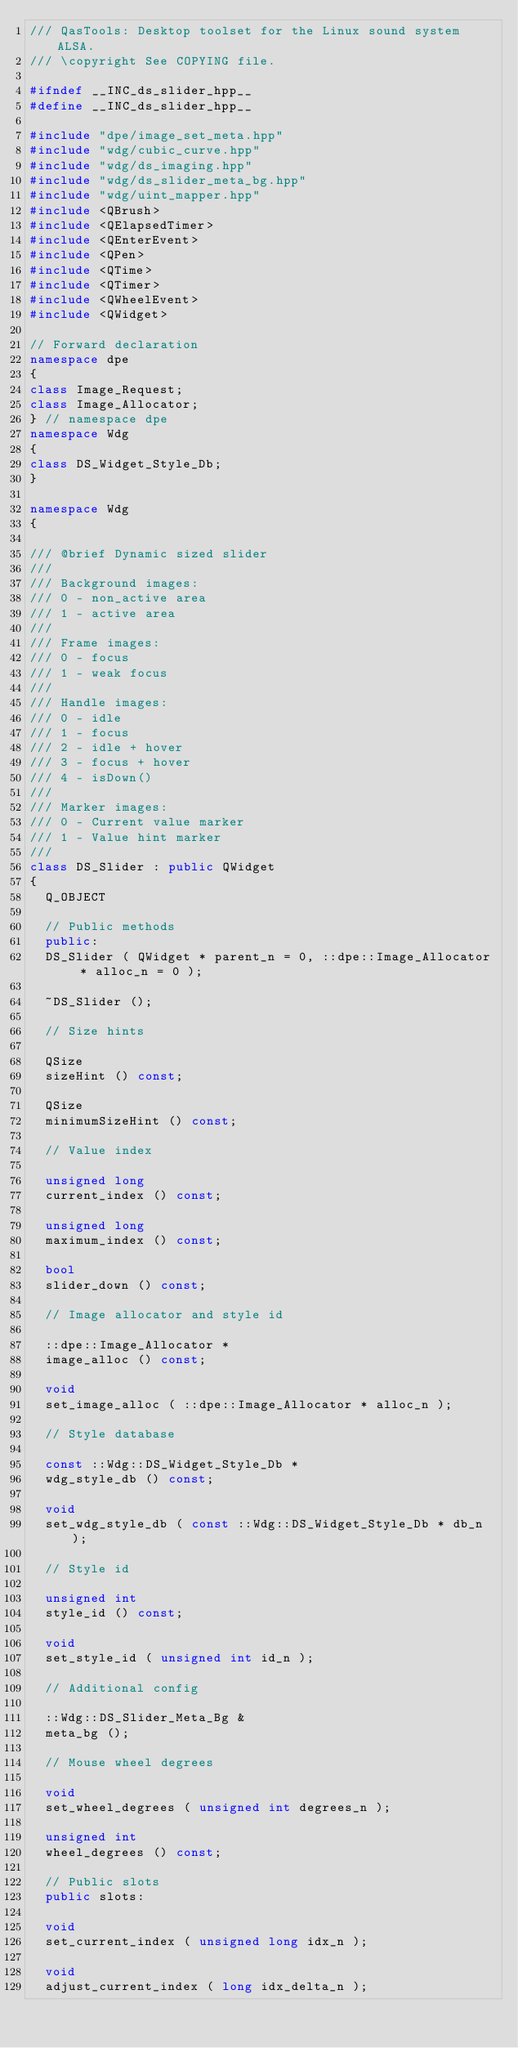<code> <loc_0><loc_0><loc_500><loc_500><_C++_>/// QasTools: Desktop toolset for the Linux sound system ALSA.
/// \copyright See COPYING file.

#ifndef __INC_ds_slider_hpp__
#define __INC_ds_slider_hpp__

#include "dpe/image_set_meta.hpp"
#include "wdg/cubic_curve.hpp"
#include "wdg/ds_imaging.hpp"
#include "wdg/ds_slider_meta_bg.hpp"
#include "wdg/uint_mapper.hpp"
#include <QBrush>
#include <QElapsedTimer>
#include <QEnterEvent>
#include <QPen>
#include <QTime>
#include <QTimer>
#include <QWheelEvent>
#include <QWidget>

// Forward declaration
namespace dpe
{
class Image_Request;
class Image_Allocator;
} // namespace dpe
namespace Wdg
{
class DS_Widget_Style_Db;
}

namespace Wdg
{

/// @brief Dynamic sized slider
///
/// Background images:
/// 0 - non_active area
/// 1 - active area
///
/// Frame images:
/// 0 - focus
/// 1 - weak focus
///
/// Handle images:
/// 0 - idle
/// 1 - focus
/// 2 - idle + hover
/// 3 - focus + hover
/// 4 - isDown()
///
/// Marker images:
/// 0 - Current value marker
/// 1 - Value hint marker
///
class DS_Slider : public QWidget
{
  Q_OBJECT

  // Public methods
  public:
  DS_Slider ( QWidget * parent_n = 0, ::dpe::Image_Allocator * alloc_n = 0 );

  ~DS_Slider ();

  // Size hints

  QSize
  sizeHint () const;

  QSize
  minimumSizeHint () const;

  // Value index

  unsigned long
  current_index () const;

  unsigned long
  maximum_index () const;

  bool
  slider_down () const;

  // Image allocator and style id

  ::dpe::Image_Allocator *
  image_alloc () const;

  void
  set_image_alloc ( ::dpe::Image_Allocator * alloc_n );

  // Style database

  const ::Wdg::DS_Widget_Style_Db *
  wdg_style_db () const;

  void
  set_wdg_style_db ( const ::Wdg::DS_Widget_Style_Db * db_n );

  // Style id

  unsigned int
  style_id () const;

  void
  set_style_id ( unsigned int id_n );

  // Additional config

  ::Wdg::DS_Slider_Meta_Bg &
  meta_bg ();

  // Mouse wheel degrees

  void
  set_wheel_degrees ( unsigned int degrees_n );

  unsigned int
  wheel_degrees () const;

  // Public slots
  public slots:

  void
  set_current_index ( unsigned long idx_n );

  void
  adjust_current_index ( long idx_delta_n );
</code> 